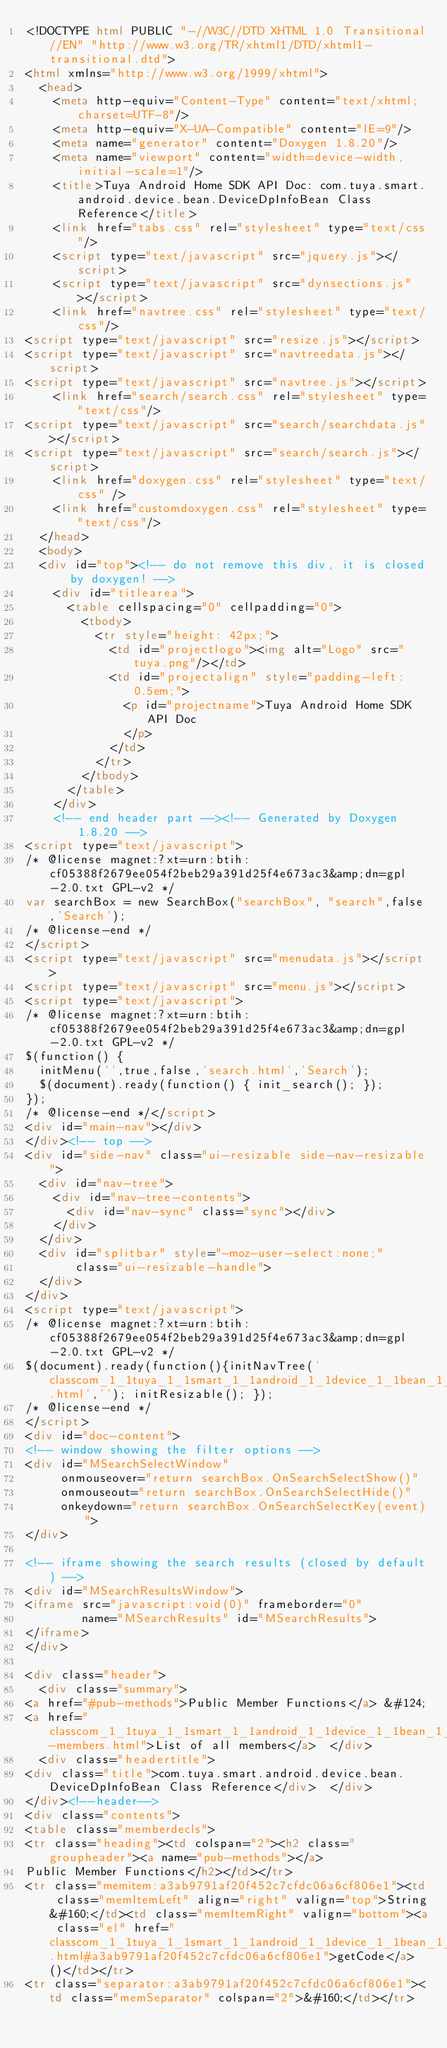Convert code to text. <code><loc_0><loc_0><loc_500><loc_500><_HTML_><!DOCTYPE html PUBLIC "-//W3C//DTD XHTML 1.0 Transitional//EN" "http://www.w3.org/TR/xhtml1/DTD/xhtml1-transitional.dtd">
<html xmlns="http://www.w3.org/1999/xhtml">
	<head>
		<meta http-equiv="Content-Type" content="text/xhtml;charset=UTF-8"/>
		<meta http-equiv="X-UA-Compatible" content="IE=9"/>
		<meta name="generator" content="Doxygen 1.8.20"/>
		<meta name="viewport" content="width=device-width, initial-scale=1"/>
		<title>Tuya Android Home SDK API Doc: com.tuya.smart.android.device.bean.DeviceDpInfoBean Class Reference</title>
		<link href="tabs.css" rel="stylesheet" type="text/css"/>
		<script type="text/javascript" src="jquery.js"></script>
		<script type="text/javascript" src="dynsections.js"></script>
		<link href="navtree.css" rel="stylesheet" type="text/css"/>
<script type="text/javascript" src="resize.js"></script>
<script type="text/javascript" src="navtreedata.js"></script>
<script type="text/javascript" src="navtree.js"></script>
		<link href="search/search.css" rel="stylesheet" type="text/css"/>
<script type="text/javascript" src="search/searchdata.js"></script>
<script type="text/javascript" src="search/search.js"></script>
		<link href="doxygen.css" rel="stylesheet" type="text/css" />
		<link href="customdoxygen.css" rel="stylesheet" type="text/css"/>
	</head>
	<body>
	<div id="top"><!-- do not remove this div, it is closed by doxygen! -->
		<div id="titlearea">
			<table cellspacing="0" cellpadding="0">
				<tbody>
					<tr style="height: 42px;">
						<td id="projectlogo"><img alt="Logo" src="tuya.png"/></td>
						<td id="projectalign" style="padding-left: 0.5em;">
							<p id="projectname">Tuya Android Home SDK API Doc
							</p>
						</td>
					</tr>
				</tbody>
			</table>
		</div>
		<!-- end header part --><!-- Generated by Doxygen 1.8.20 -->
<script type="text/javascript">
/* @license magnet:?xt=urn:btih:cf05388f2679ee054f2beb29a391d25f4e673ac3&amp;dn=gpl-2.0.txt GPL-v2 */
var searchBox = new SearchBox("searchBox", "search",false,'Search');
/* @license-end */
</script>
<script type="text/javascript" src="menudata.js"></script>
<script type="text/javascript" src="menu.js"></script>
<script type="text/javascript">
/* @license magnet:?xt=urn:btih:cf05388f2679ee054f2beb29a391d25f4e673ac3&amp;dn=gpl-2.0.txt GPL-v2 */
$(function() {
  initMenu('',true,false,'search.html','Search');
  $(document).ready(function() { init_search(); });
});
/* @license-end */</script>
<div id="main-nav"></div>
</div><!-- top -->
<div id="side-nav" class="ui-resizable side-nav-resizable">
  <div id="nav-tree">
    <div id="nav-tree-contents">
      <div id="nav-sync" class="sync"></div>
    </div>
  </div>
  <div id="splitbar" style="-moz-user-select:none;" 
       class="ui-resizable-handle">
  </div>
</div>
<script type="text/javascript">
/* @license magnet:?xt=urn:btih:cf05388f2679ee054f2beb29a391d25f4e673ac3&amp;dn=gpl-2.0.txt GPL-v2 */
$(document).ready(function(){initNavTree('classcom_1_1tuya_1_1smart_1_1android_1_1device_1_1bean_1_1_device_dp_info_bean.html',''); initResizable(); });
/* @license-end */
</script>
<div id="doc-content">
<!-- window showing the filter options -->
<div id="MSearchSelectWindow"
     onmouseover="return searchBox.OnSearchSelectShow()"
     onmouseout="return searchBox.OnSearchSelectHide()"
     onkeydown="return searchBox.OnSearchSelectKey(event)">
</div>

<!-- iframe showing the search results (closed by default) -->
<div id="MSearchResultsWindow">
<iframe src="javascript:void(0)" frameborder="0" 
        name="MSearchResults" id="MSearchResults">
</iframe>
</div>

<div class="header">
  <div class="summary">
<a href="#pub-methods">Public Member Functions</a> &#124;
<a href="classcom_1_1tuya_1_1smart_1_1android_1_1device_1_1bean_1_1_device_dp_info_bean-members.html">List of all members</a>  </div>
  <div class="headertitle">
<div class="title">com.tuya.smart.android.device.bean.DeviceDpInfoBean Class Reference</div>  </div>
</div><!--header-->
<div class="contents">
<table class="memberdecls">
<tr class="heading"><td colspan="2"><h2 class="groupheader"><a name="pub-methods"></a>
Public Member Functions</h2></td></tr>
<tr class="memitem:a3ab9791af20f452c7cfdc06a6cf806e1"><td class="memItemLeft" align="right" valign="top">String&#160;</td><td class="memItemRight" valign="bottom"><a class="el" href="classcom_1_1tuya_1_1smart_1_1android_1_1device_1_1bean_1_1_device_dp_info_bean.html#a3ab9791af20f452c7cfdc06a6cf806e1">getCode</a> ()</td></tr>
<tr class="separator:a3ab9791af20f452c7cfdc06a6cf806e1"><td class="memSeparator" colspan="2">&#160;</td></tr></code> 